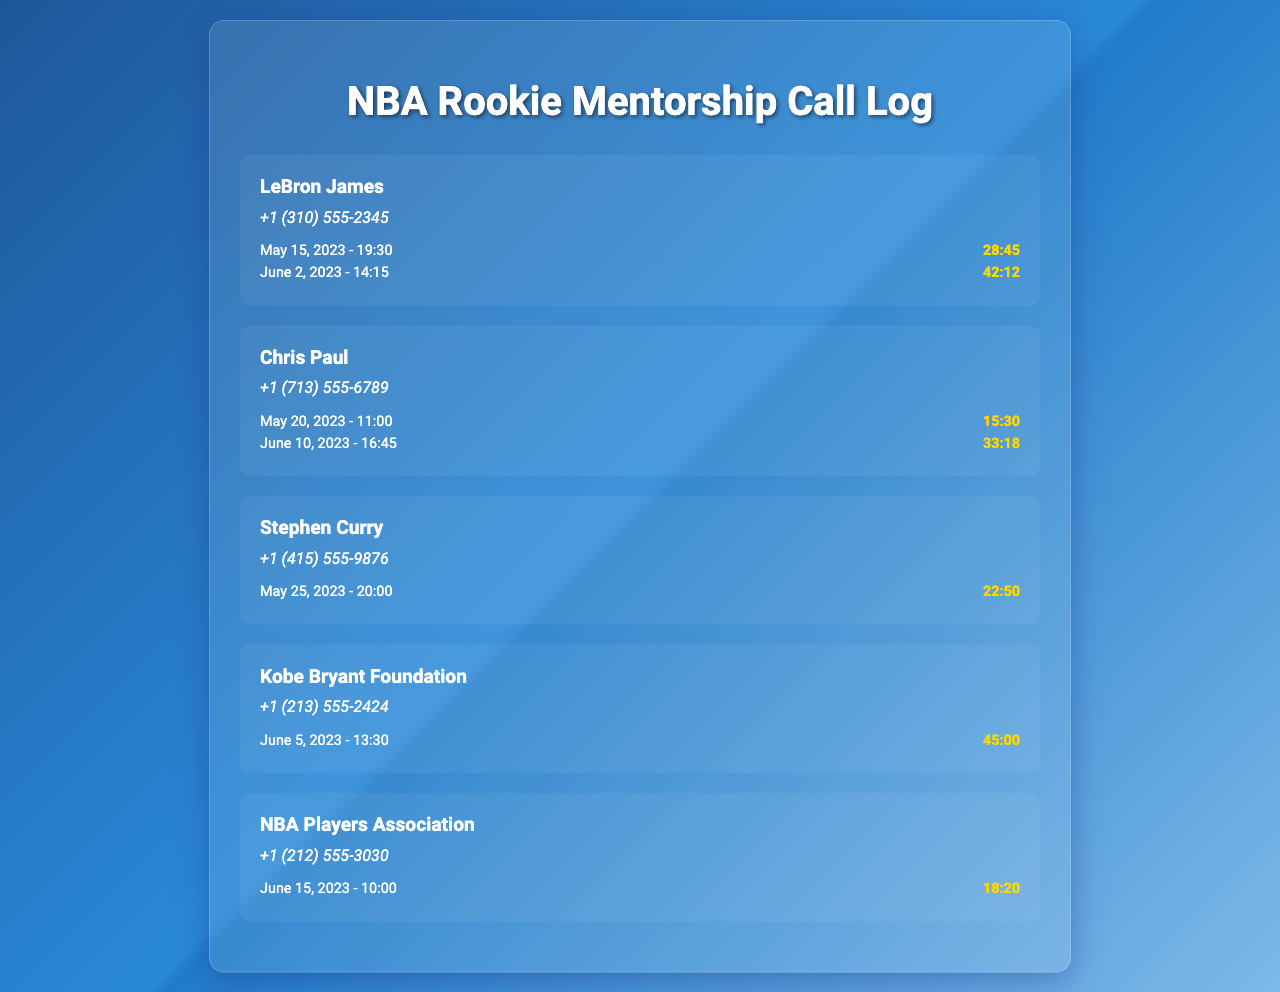what is the contact name for the first record? The first record lists the contact as LeBron James.
Answer: LeBron James how many calls were made to Chris Paul? There are two calls listed in the record for Chris Paul.
Answer: 2 which player had a call on June 10, 2023? The call on June 10, 2023, was made to Chris Paul.
Answer: Chris Paul what is the duration of the call with Stephen Curry? The call with Stephen Curry lasted for 22 minutes and 50 seconds.
Answer: 22:50 who is associated with the phone number +1 (213) 555-2424? The number belongs to the Kobe Bryant Foundation.
Answer: Kobe Bryant Foundation which call had the longest duration? The longest call duration is 45 minutes, made on June 5, 2023.
Answer: 45:00 on what date was the call with LeBron James made? The calls with LeBron James were made on May 15 and June 2, 2023.
Answer: May 15, June 2 how many calls were made after June 1, 2023? A total of three calls were made after June 1, 2023.
Answer: 3 what organization is listed after Chris Paul? The next organization listed after Chris Paul is Stephen Curry.
Answer: Stephen Curry 